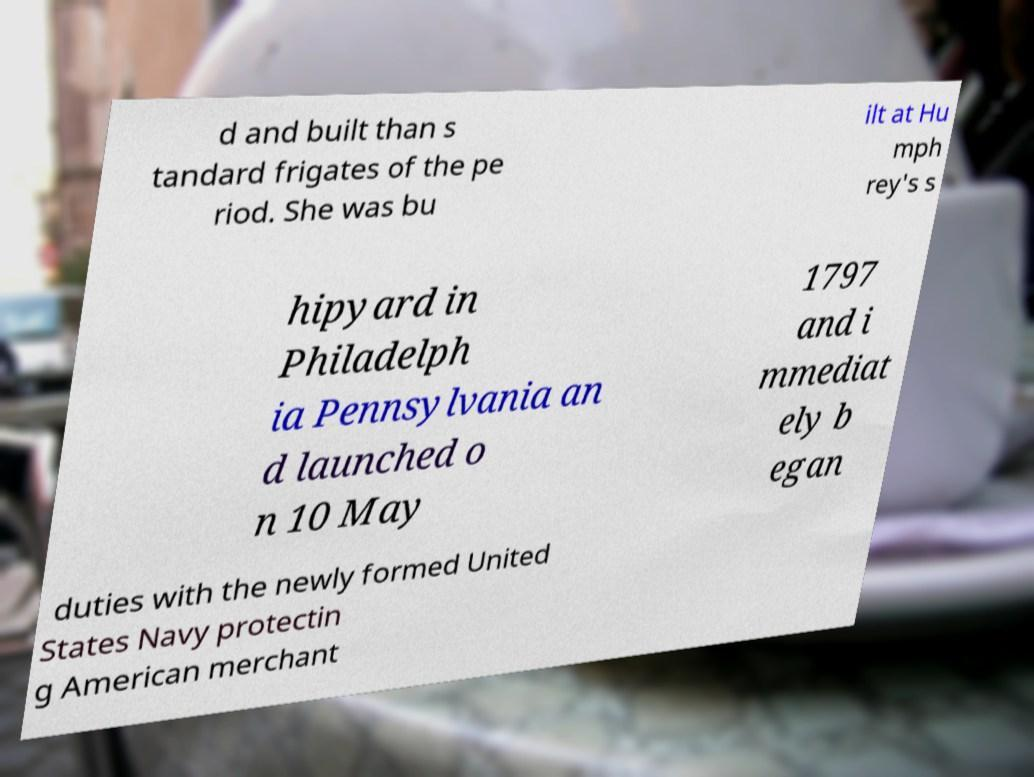There's text embedded in this image that I need extracted. Can you transcribe it verbatim? d and built than s tandard frigates of the pe riod. She was bu ilt at Hu mph rey's s hipyard in Philadelph ia Pennsylvania an d launched o n 10 May 1797 and i mmediat ely b egan duties with the newly formed United States Navy protectin g American merchant 